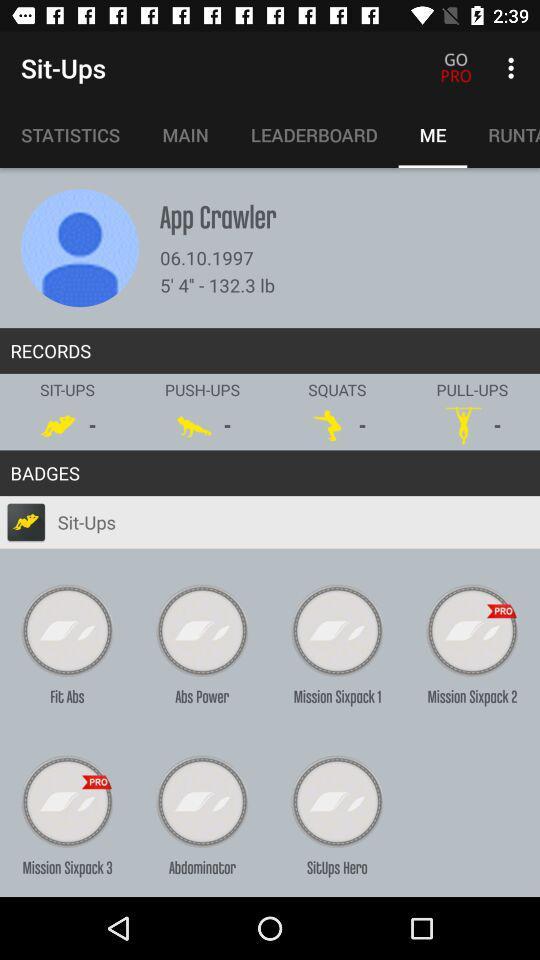What is the date of birth of the user? The date of birth of the user is 06.10.1997. 